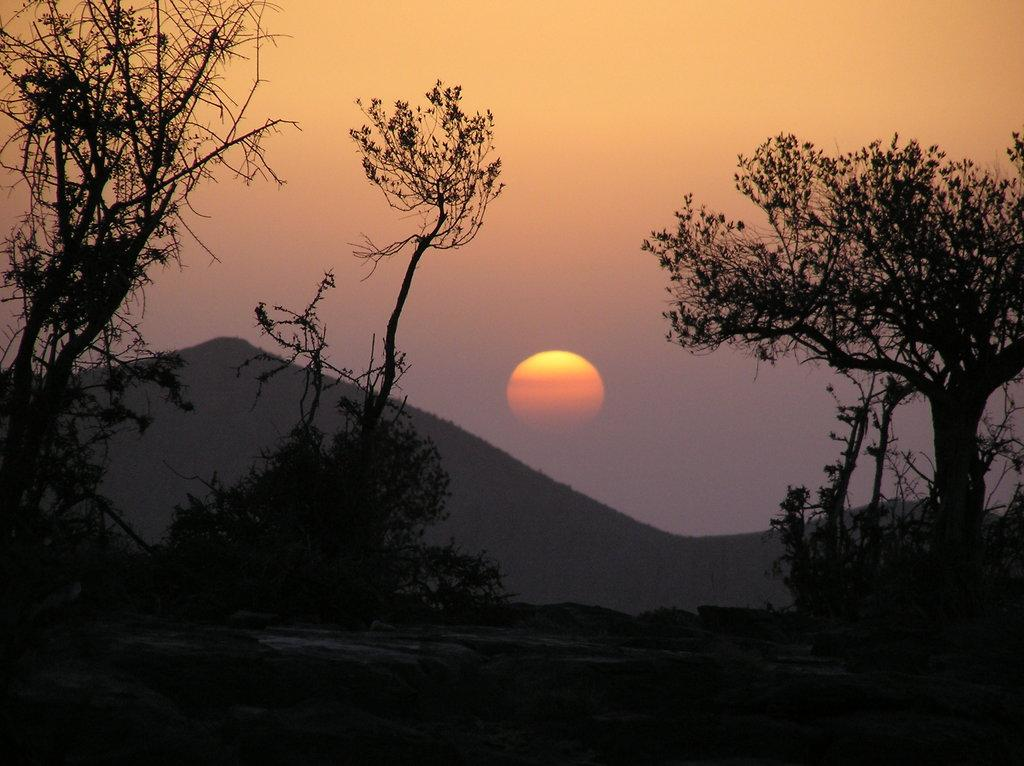What type of view is shown in the image? The image depicts a sunset view. What can be seen in the foreground of the image? There are trees in the front and center in the image. What is visible in the background of the image? The sun and mountains are visible in the background of the image. What is the color of the sun in the image? The sun has an orange color. How many cans of soda are visible in the image? There are no cans of soda present in the image. What type of comfort can be found in the image? The image does not depict any specific type of comfort; it is a scenic view of a sunset. 